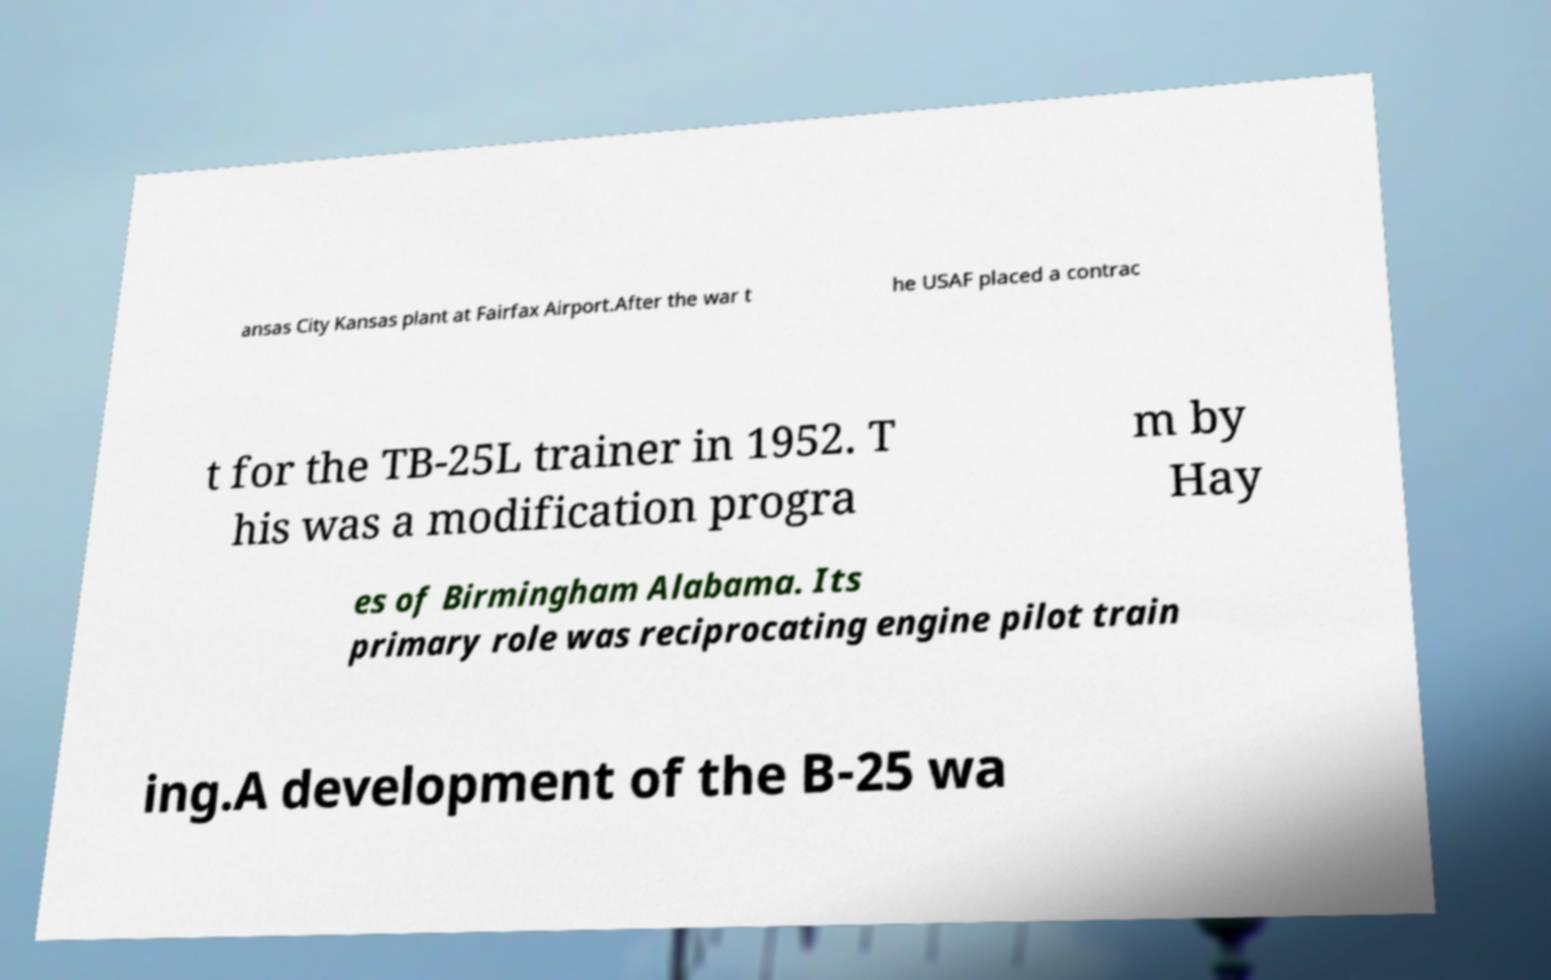Can you read and provide the text displayed in the image?This photo seems to have some interesting text. Can you extract and type it out for me? ansas City Kansas plant at Fairfax Airport.After the war t he USAF placed a contrac t for the TB-25L trainer in 1952. T his was a modification progra m by Hay es of Birmingham Alabama. Its primary role was reciprocating engine pilot train ing.A development of the B-25 wa 